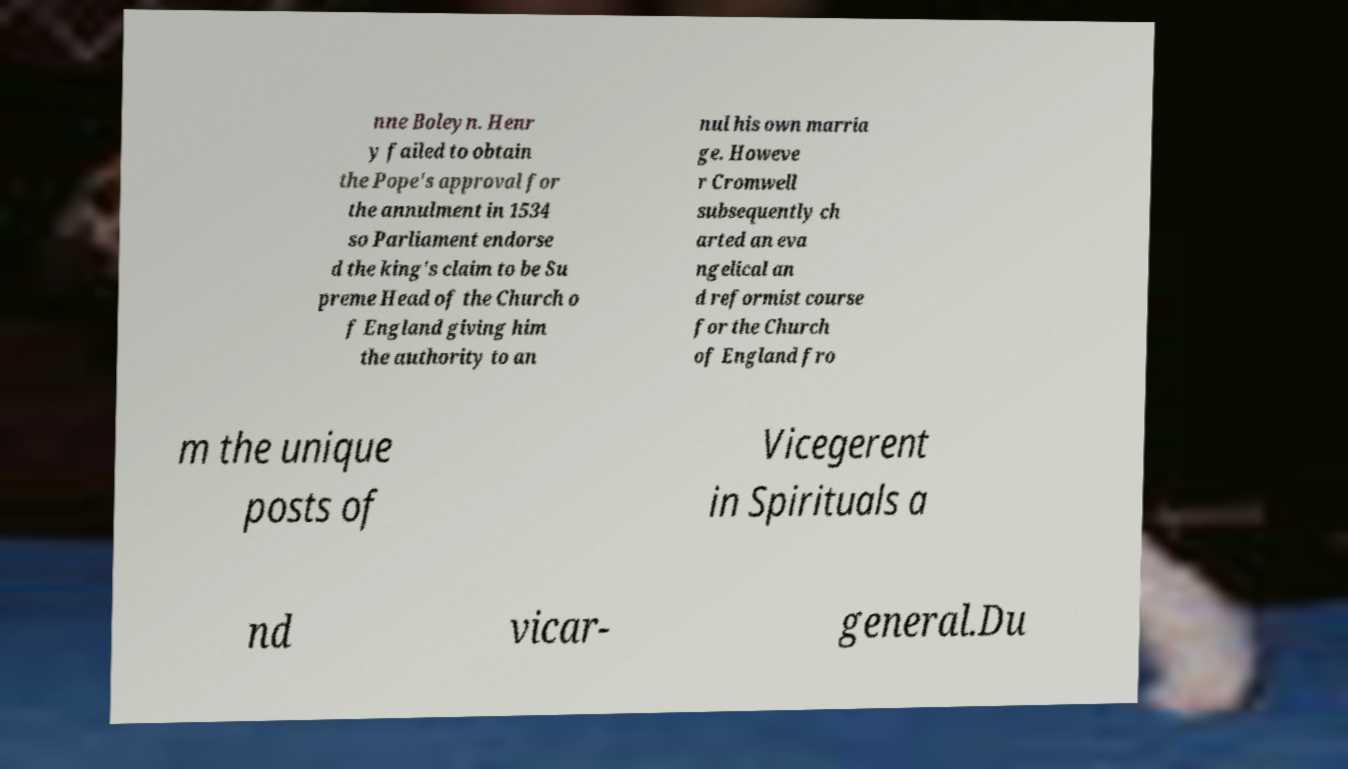Could you assist in decoding the text presented in this image and type it out clearly? nne Boleyn. Henr y failed to obtain the Pope's approval for the annulment in 1534 so Parliament endorse d the king's claim to be Su preme Head of the Church o f England giving him the authority to an nul his own marria ge. Howeve r Cromwell subsequently ch arted an eva ngelical an d reformist course for the Church of England fro m the unique posts of Vicegerent in Spirituals a nd vicar- general.Du 